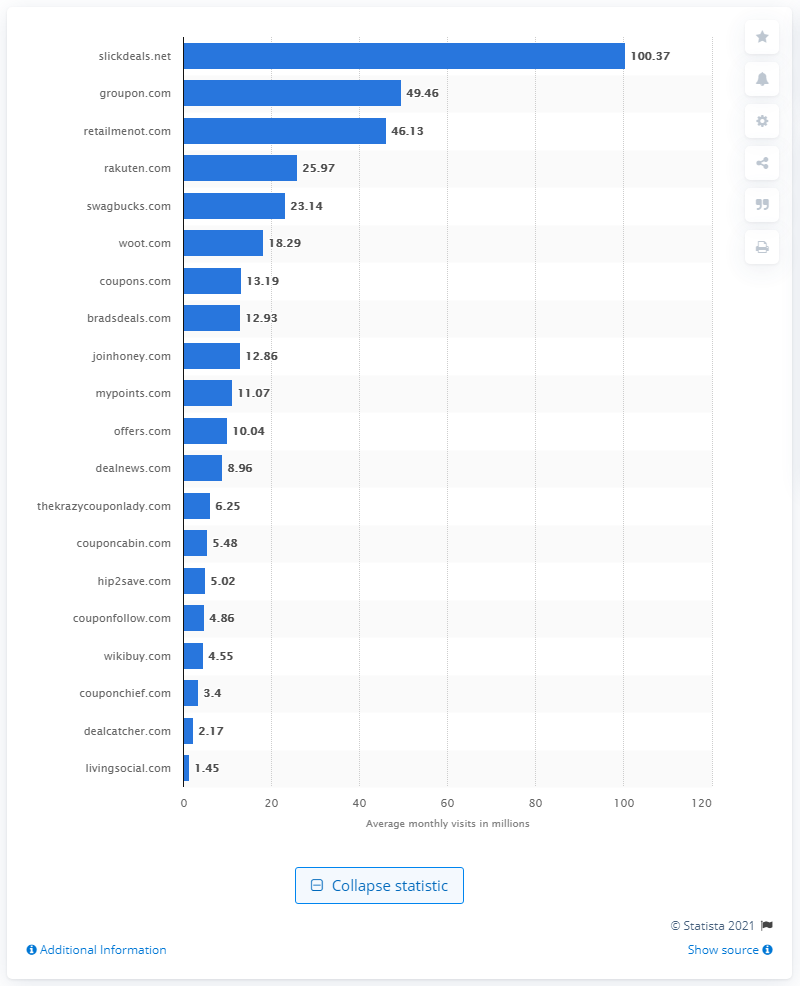Outline some significant characteristics in this image. In June of 2020, it is estimated that approximately 100,370 people visited the website slickdeals.net. 